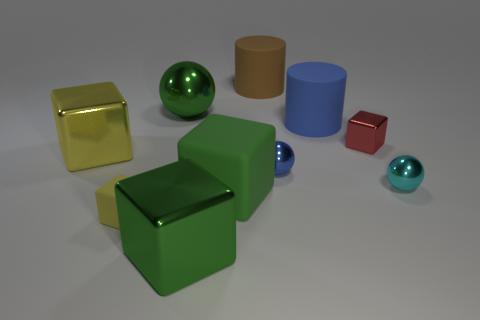Is the large shiny ball the same color as the large matte block?
Ensure brevity in your answer.  Yes. What number of other things are there of the same shape as the small red metallic thing?
Make the answer very short. 4. Is the number of small cubes that are to the left of the large rubber cube greater than the number of big green matte things behind the brown cylinder?
Your answer should be compact. Yes. Does the yellow block behind the blue metal object have the same size as the shiny thing in front of the big rubber cube?
Ensure brevity in your answer.  Yes. There is a tiny cyan shiny object; what shape is it?
Ensure brevity in your answer.  Sphere. The cube that is the same color as the small rubber object is what size?
Make the answer very short. Large. There is a tiny block that is the same material as the green ball; what is its color?
Your response must be concise. Red. Is the small yellow block made of the same material as the cylinder behind the big blue cylinder?
Ensure brevity in your answer.  Yes. What color is the small matte object?
Make the answer very short. Yellow. There is a green thing that is made of the same material as the blue cylinder; what is its size?
Offer a terse response. Large. 